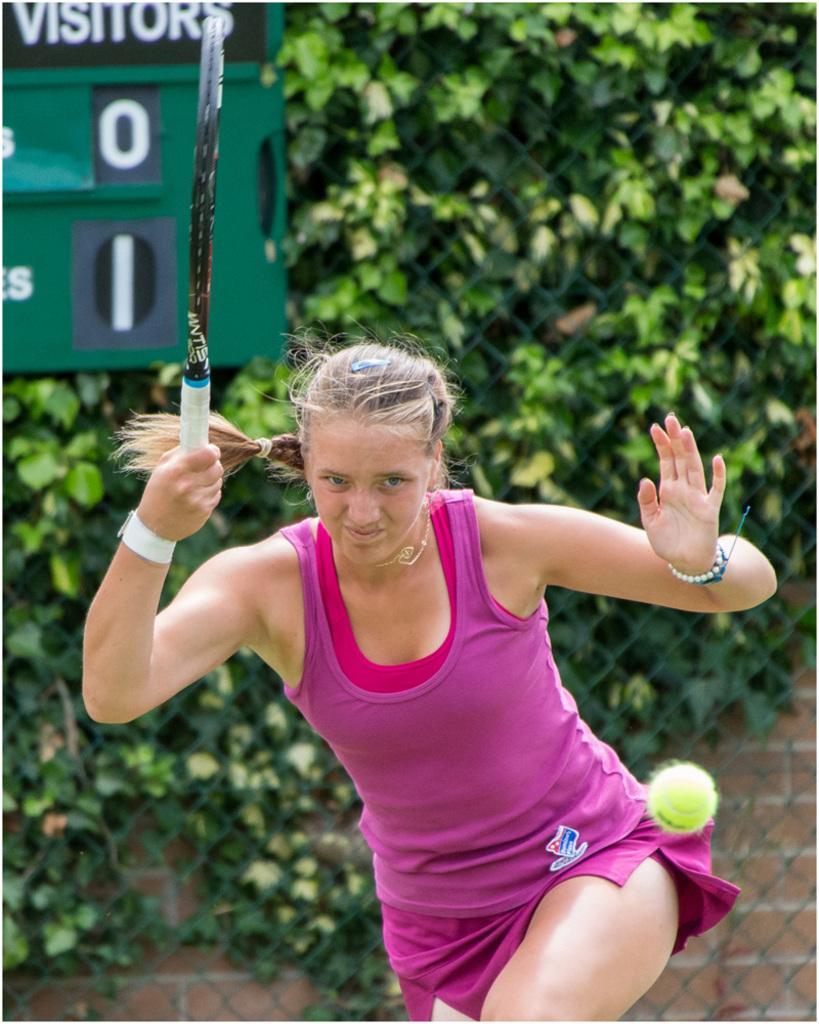Could you give a brief overview of what you see in this image? As we can see in the image there are trees and a woman holding shuttle bat. 